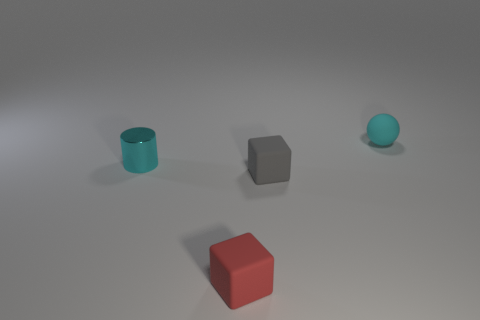Add 1 blocks. How many objects exist? 5 Subtract all balls. How many objects are left? 3 Add 4 cyan metallic things. How many cyan metallic things exist? 5 Subtract all red blocks. How many blocks are left? 1 Subtract 0 gray cylinders. How many objects are left? 4 Subtract 1 balls. How many balls are left? 0 Subtract all red spheres. Subtract all yellow cubes. How many spheres are left? 1 Subtract all purple cylinders. How many purple balls are left? 0 Subtract all small cyan shiny objects. Subtract all large yellow metal cylinders. How many objects are left? 3 Add 1 cyan rubber things. How many cyan rubber things are left? 2 